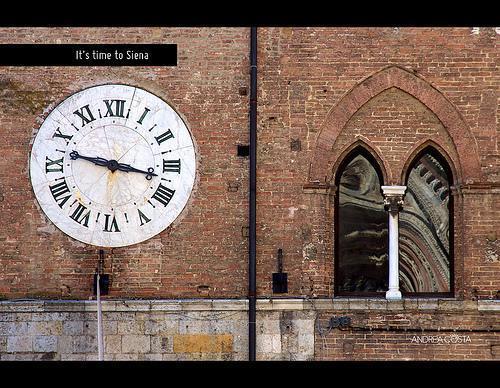How many clocks?
Give a very brief answer. 1. 